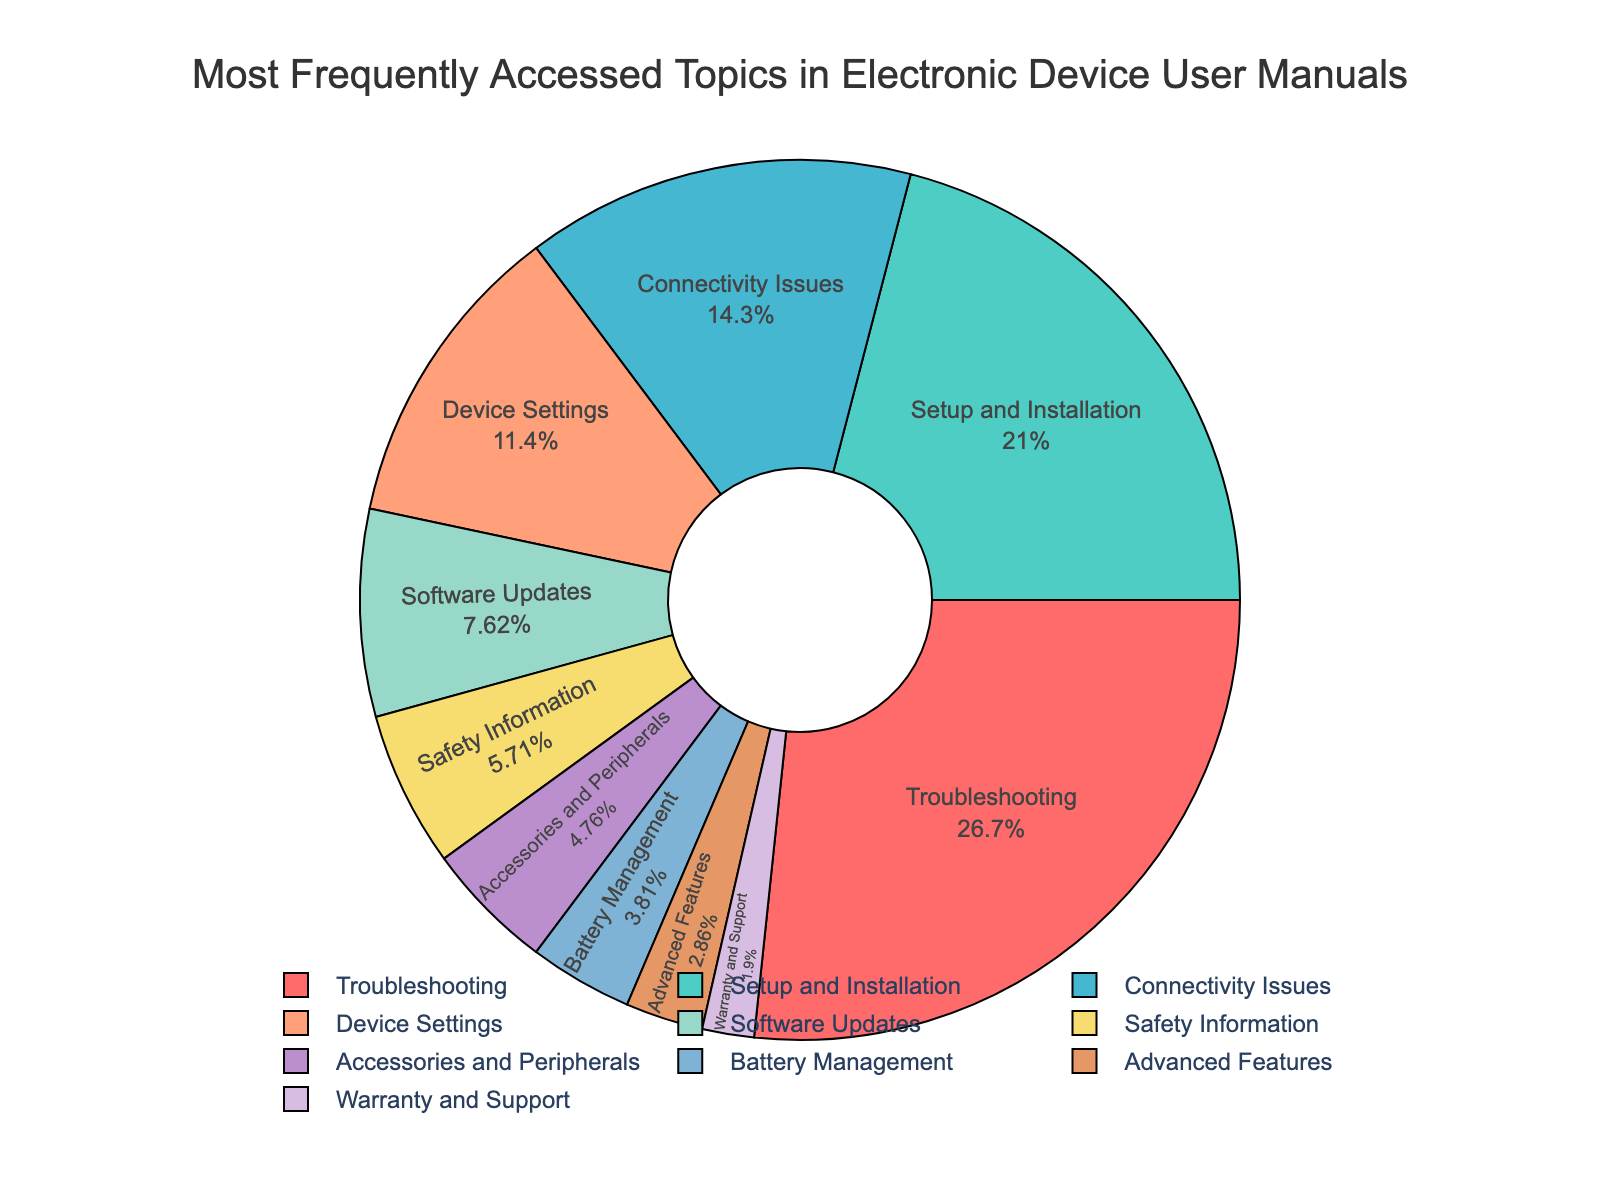what is the most frequently accessed topic in the figure? By looking at the percentage values in the pie chart, the segment with the highest percentage represents the most frequently accessed topic. Troubleshooting has the highest percentage at 28%.
Answer: Troubleshooting Which topic takes up more space in the chart, Connectivity Issues or Safety Information? To compare the two topics, we look at their respective percentages in the pie chart. Connectivity Issues has 15% while Safety Information has 6%, indicating Connectivity Issues occupies more space.
Answer: Connectivity Issues What is the combined percentage of Software Updates, Battery Management, and Warranty and Support? Adding the percentages for each of the three topics gives us 8% (Software Updates) + 4% (Battery Management) + 2% (Warranty and Support) = 14%.
Answer: 14% If you combine the percentage of Setup and Installation with that of Accessories and Peripherals, does it surpass Troubleshooting? The percentage for Setup and Installation is 22%, and for Accessories and Peripherals is 5%. Combined, their total is 22% + 5% = 27%, which is less than Troubleshooting's 28%.
Answer: No What is the difference in percentage between the most and least accessed topics? The most accessed topic is Troubleshooting at 28% and the least accessed topic is Warranty and Support at 2%. The difference is 28% - 2% = 26%.
Answer: 26% Which segments are represented with colors influenced by red hues? Observing the pie chart, we identify segments colored influenced by red hues as Troubleshooting (red) and Connectivity Issues (light salmon).
Answer: Troubleshooting and Connectivity Issues What percentage of topics are related to device upkeep and maintenance (i.e., Troubleshooting, Software Updates, Battery Management)? Combining these topics' percentages: 28% (Troubleshooting) + 8% (Software Updates) + 4% (Battery Management) = 40%.
Answer: 40% Is the percentage of Advanced Features higher or lower than that of Device Settings? By comparing the respective percentages in the pie chart, Advanced Features is 3% and Device Settings is 12%. Therefore, Advanced Features is lower than Device Settings.
Answer: Lower 